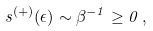<formula> <loc_0><loc_0><loc_500><loc_500>s ^ { ( + ) } ( \epsilon ) \sim \beta ^ { - 1 } \geq 0 \, ,</formula> 